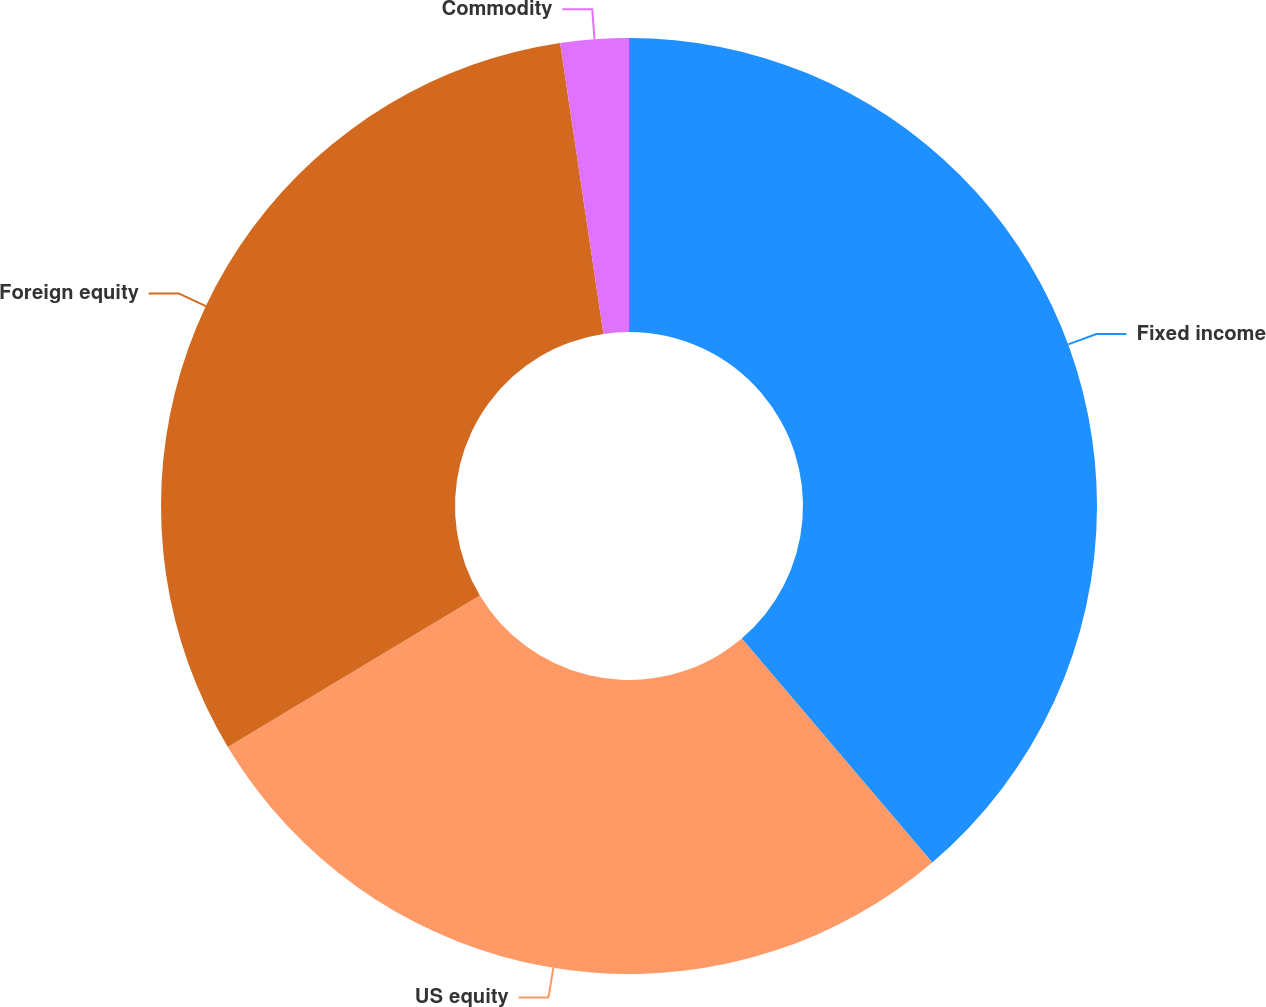<chart> <loc_0><loc_0><loc_500><loc_500><pie_chart><fcel>Fixed income<fcel>US equity<fcel>Foreign equity<fcel>Commodity<nl><fcel>38.78%<fcel>27.61%<fcel>31.26%<fcel>2.35%<nl></chart> 